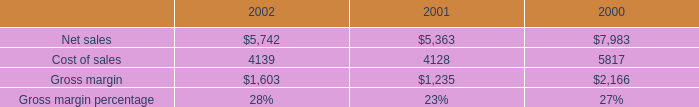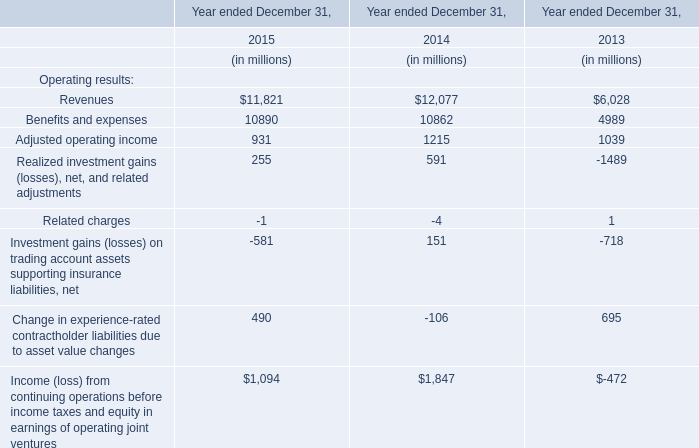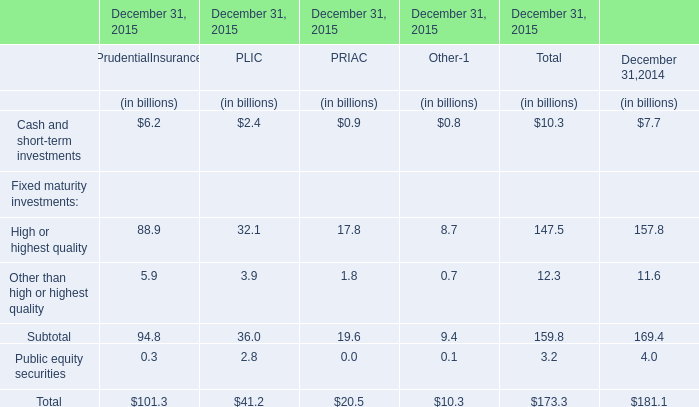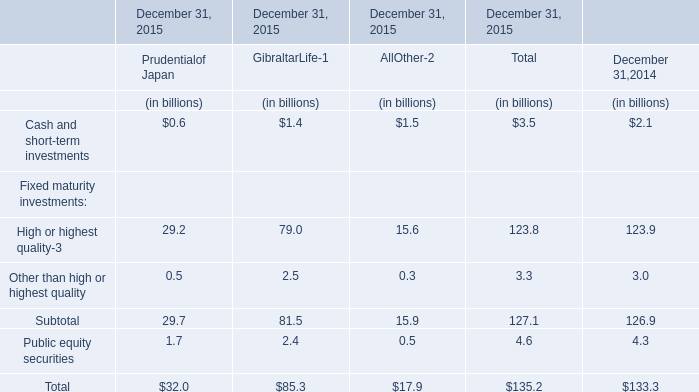What is the ratio of all elements for Total that are smaller than 120 to the sum of elements, in 2015? 
Computations: (((3.5 + 3.3) + 4.6) / 135.2)
Answer: 0.08432. 